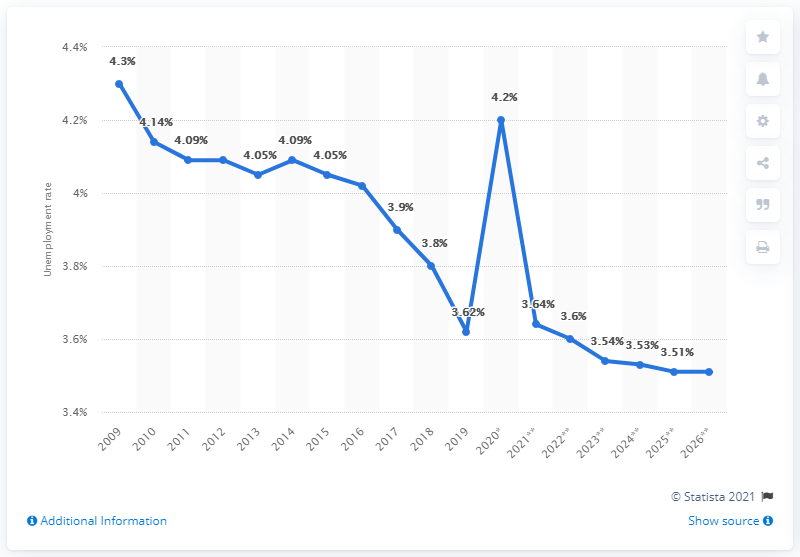Point out several critical features in this image. In 2019, the unemployment rate in urban areas of China was 3.6%. In 2020, the unemployment rate was 4.2%. 